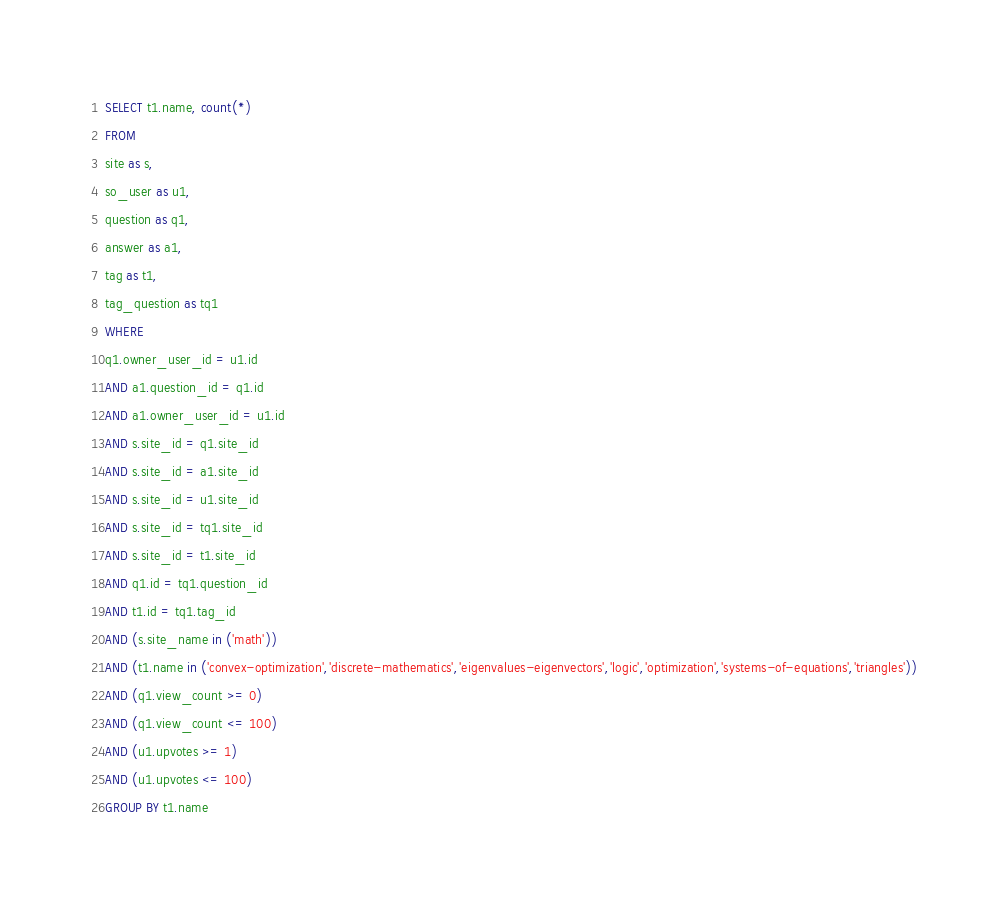<code> <loc_0><loc_0><loc_500><loc_500><_SQL_>SELECT t1.name, count(*)
FROM
site as s,
so_user as u1,
question as q1,
answer as a1,
tag as t1,
tag_question as tq1
WHERE
q1.owner_user_id = u1.id
AND a1.question_id = q1.id
AND a1.owner_user_id = u1.id
AND s.site_id = q1.site_id
AND s.site_id = a1.site_id
AND s.site_id = u1.site_id
AND s.site_id = tq1.site_id
AND s.site_id = t1.site_id
AND q1.id = tq1.question_id
AND t1.id = tq1.tag_id
AND (s.site_name in ('math'))
AND (t1.name in ('convex-optimization','discrete-mathematics','eigenvalues-eigenvectors','logic','optimization','systems-of-equations','triangles'))
AND (q1.view_count >= 0)
AND (q1.view_count <= 100)
AND (u1.upvotes >= 1)
AND (u1.upvotes <= 100)
GROUP BY t1.name</code> 